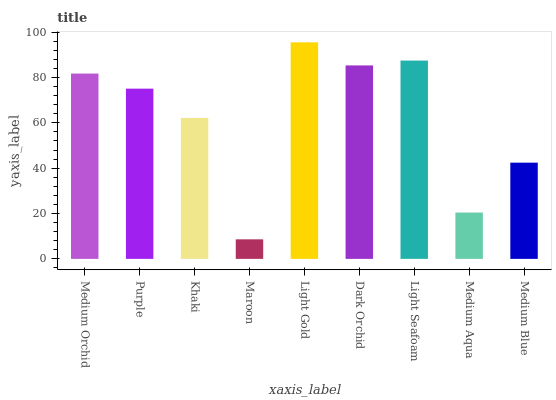Is Purple the minimum?
Answer yes or no. No. Is Purple the maximum?
Answer yes or no. No. Is Medium Orchid greater than Purple?
Answer yes or no. Yes. Is Purple less than Medium Orchid?
Answer yes or no. Yes. Is Purple greater than Medium Orchid?
Answer yes or no. No. Is Medium Orchid less than Purple?
Answer yes or no. No. Is Purple the high median?
Answer yes or no. Yes. Is Purple the low median?
Answer yes or no. Yes. Is Medium Aqua the high median?
Answer yes or no. No. Is Medium Blue the low median?
Answer yes or no. No. 